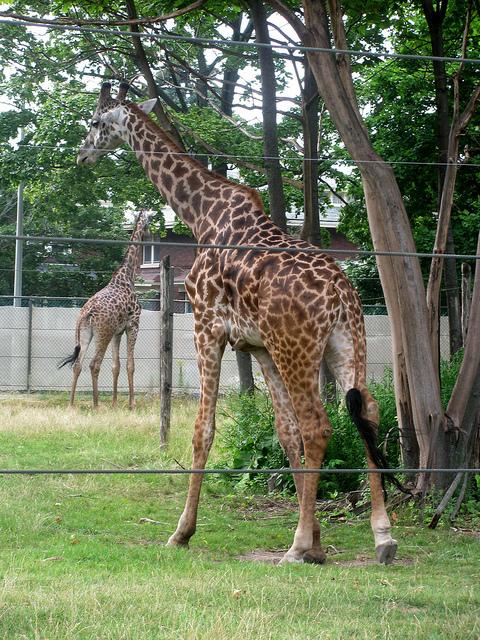Are they both facing the same way?
Keep it brief. No. Are these giraffe ready to eat grass?
Give a very brief answer. No. Where is the baby mother?
Give a very brief answer. Separate pen. Where is the rear giraffe's front right hoof?
Give a very brief answer. On ground. How many giraffes are there?
Quick response, please. 2. Where are the giraffes?
Keep it brief. Zoo. What animal is in the background on the left?
Answer briefly. Giraffe. 